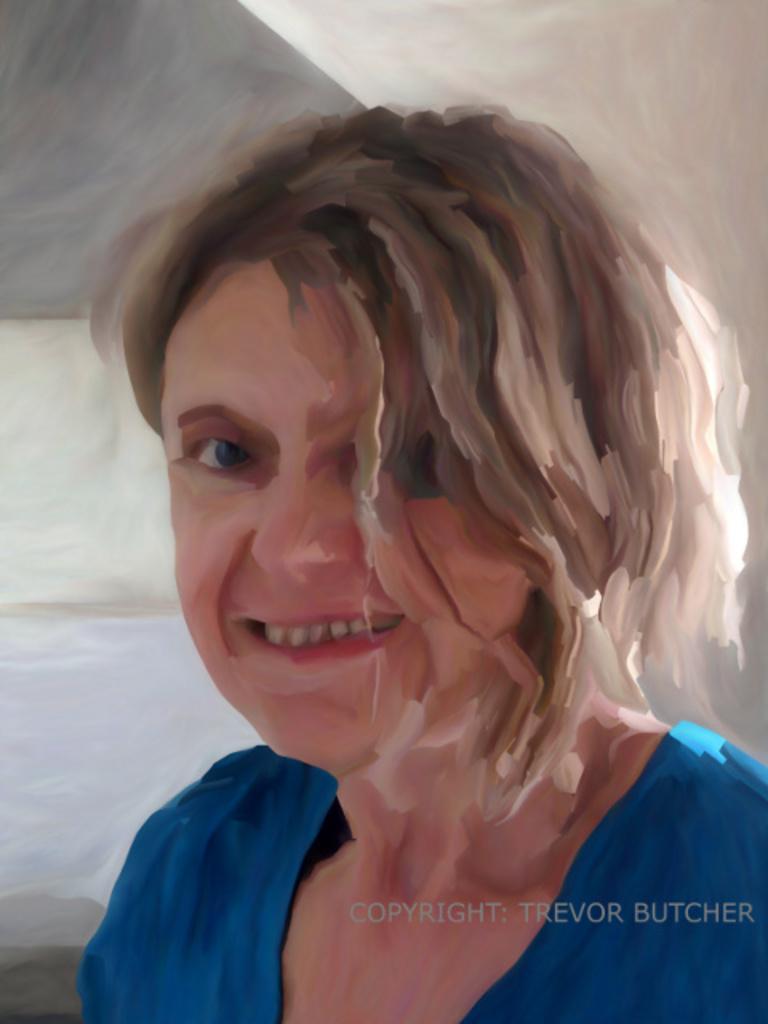How would you summarize this image in a sentence or two? This is a painting and in this painting we can see a woman smiling. 